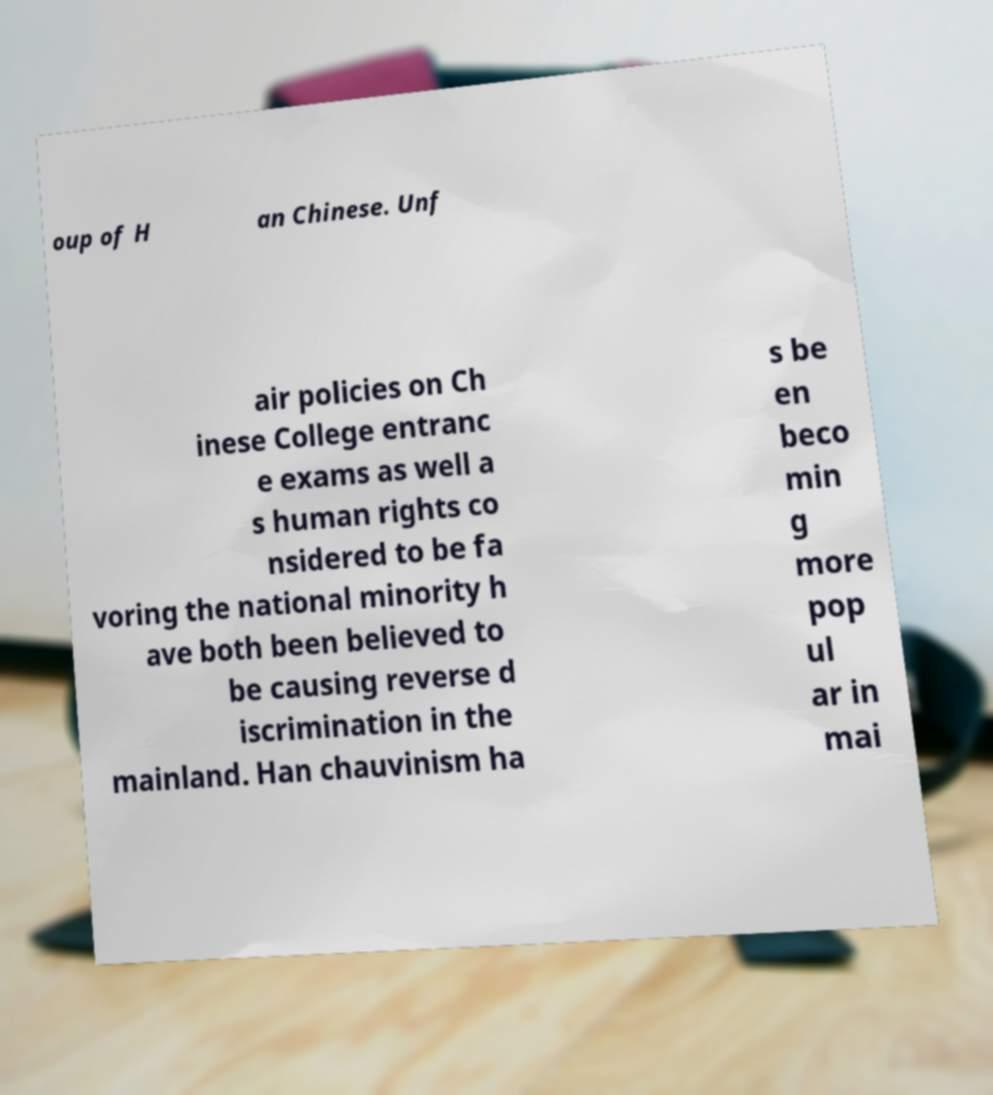I need the written content from this picture converted into text. Can you do that? oup of H an Chinese. Unf air policies on Ch inese College entranc e exams as well a s human rights co nsidered to be fa voring the national minority h ave both been believed to be causing reverse d iscrimination in the mainland. Han chauvinism ha s be en beco min g more pop ul ar in mai 